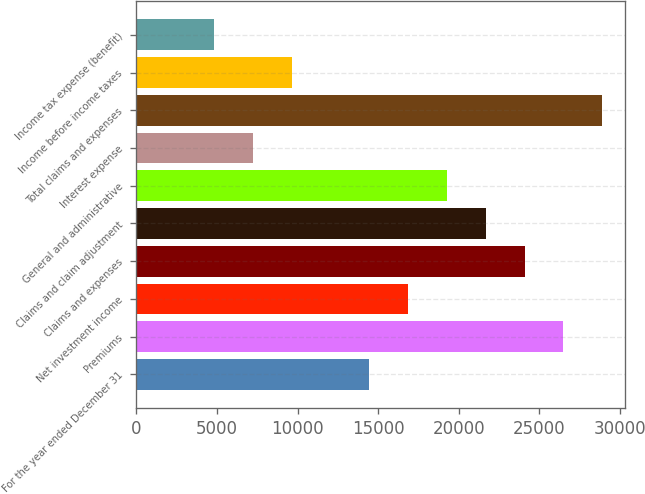<chart> <loc_0><loc_0><loc_500><loc_500><bar_chart><fcel>For the year ended December 31<fcel>Premiums<fcel>Net investment income<fcel>Claims and expenses<fcel>Claims and claim adjustment<fcel>General and administrative<fcel>Interest expense<fcel>Total claims and expenses<fcel>Income before income taxes<fcel>Income tax expense (benefit)<nl><fcel>14457.7<fcel>26503<fcel>16866.8<fcel>24094<fcel>21684.9<fcel>19275.8<fcel>7230.54<fcel>28912.1<fcel>9639.6<fcel>4821.48<nl></chart> 